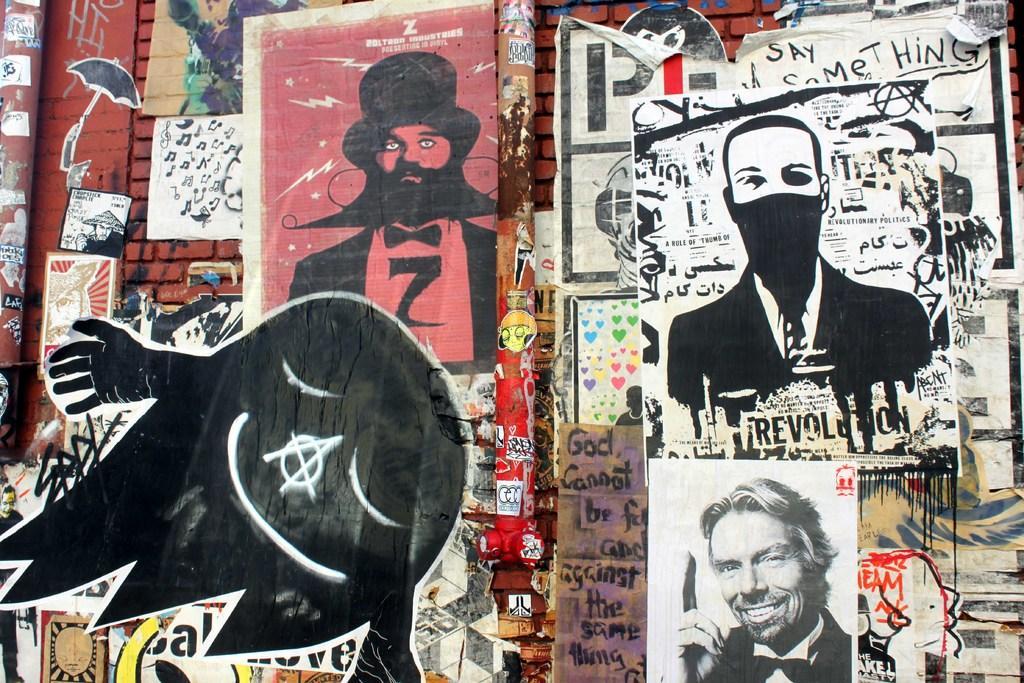Could you give a brief overview of what you see in this image? In this picture I can see photographs, paintings, stickers on the wall. 